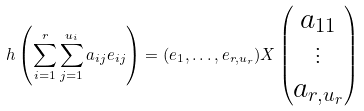<formula> <loc_0><loc_0><loc_500><loc_500>h \left ( \sum _ { i = 1 } ^ { r } \sum _ { j = 1 } ^ { u _ { i } } a _ { i j } e _ { i j } \right ) = ( e _ { 1 } , \dots , e _ { r , u _ { r } } ) X \begin{pmatrix} a _ { 1 1 } \\ \vdots \\ a _ { r , u _ { r } } \\ \end{pmatrix}</formula> 